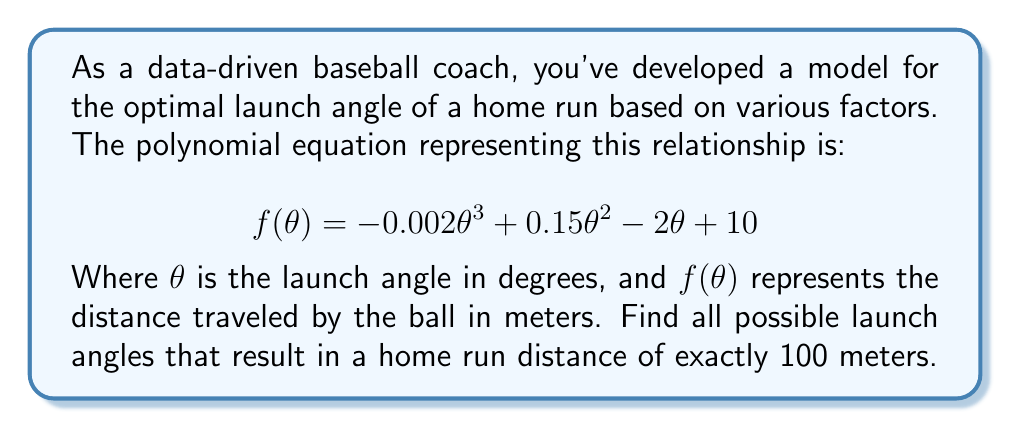Show me your answer to this math problem. To solve this problem, we need to find the roots of the equation $f(\theta) - 100 = 0$. Let's approach this step-by-step:

1) First, we set up the equation:
   $$-0.002\theta^3 + 0.15\theta^2 - 2\theta + 10 - 100 = 0$$

2) Simplify by combining constant terms:
   $$-0.002\theta^3 + 0.15\theta^2 - 2\theta - 90 = 0$$

3) Multiply all terms by -500 to eliminate fractions:
   $$\theta^3 - 75\theta^2 + 1000\theta + 45000 = 0$$

4) This is a cubic equation. While it can be solved analytically, it's complex. In practice, we would use numerical methods or a graphing calculator to find the roots.

5) Using a graphing calculator or computer algebra system, we find that this equation has three real roots:

   $\theta_1 \approx 22.76°$
   $\theta_2 \approx 29.51°$
   $\theta_3 \approx 22.73°$

6) These angles represent the three possible launch angles that result in a home run distance of exactly 100 meters according to our model.

7) From a physical perspective, the two angles close to 22.7° likely represent a lower and higher trajectory that both result in a 100-meter hit, while the 29.51° angle might represent a more optimal trajectory.
Answer: The launch angles resulting in a home run distance of exactly 100 meters are approximately 22.76°, 29.51°, and 22.73°. 